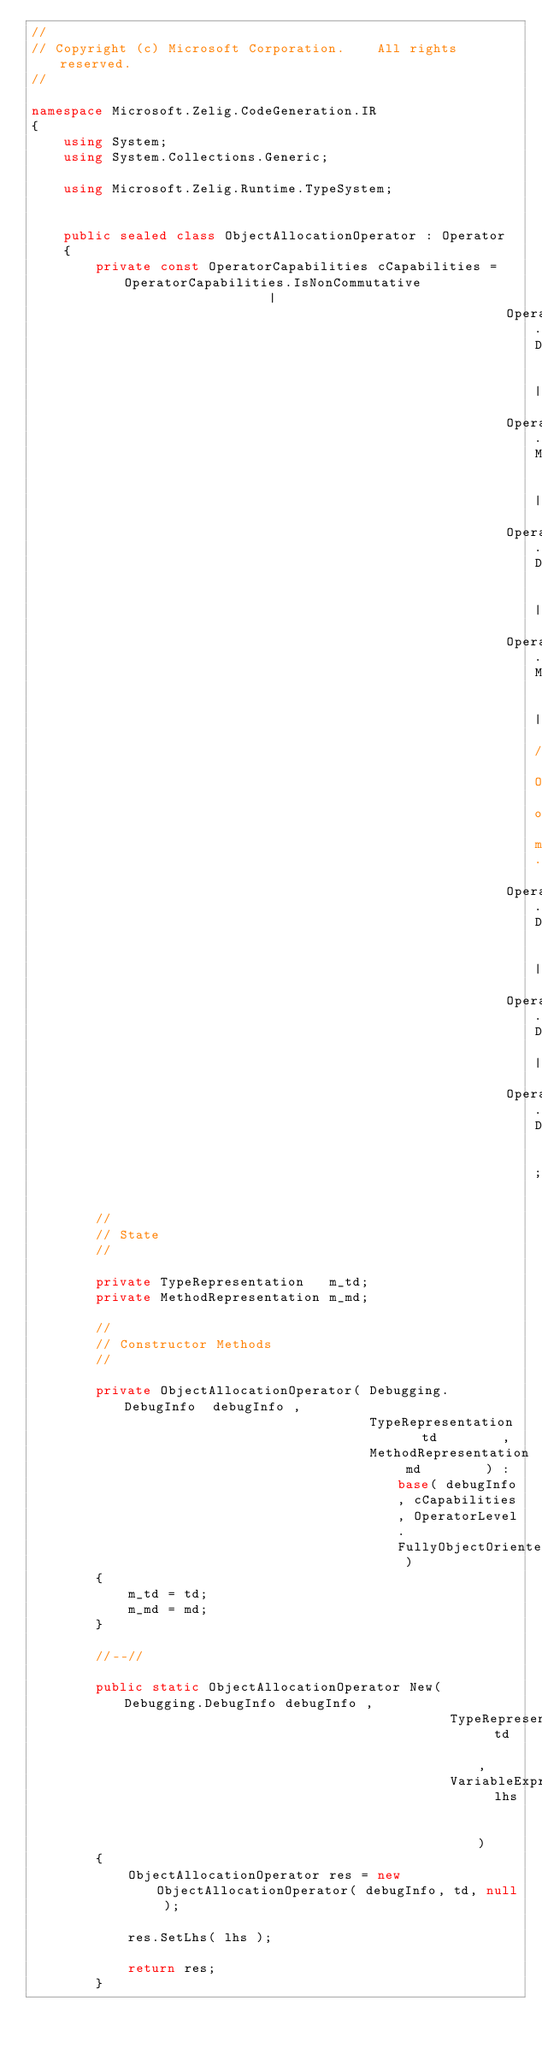Convert code to text. <code><loc_0><loc_0><loc_500><loc_500><_C#_>//
// Copyright (c) Microsoft Corporation.    All rights reserved.
//

namespace Microsoft.Zelig.CodeGeneration.IR
{
    using System;
    using System.Collections.Generic;

    using Microsoft.Zelig.Runtime.TypeSystem;


    public sealed class ObjectAllocationOperator : Operator
    {
        private const OperatorCapabilities cCapabilities = OperatorCapabilities.IsNonCommutative                   |
                                                           OperatorCapabilities.DoesNotMutateExistingStorage       |
                                                           OperatorCapabilities.MayAllocateStorage                 |
                                                           OperatorCapabilities.DoesNotReadExistingMutableStorage  |
                                                           OperatorCapabilities.MayThrow                           | // Out of memory.
                                                           OperatorCapabilities.DoesNotReadThroughPointerOperands  |
                                                           OperatorCapabilities.DoesNotWriteThroughPointerOperands |
                                                           OperatorCapabilities.DoesNotCapturePointerOperands      ;

        //
        // State
        //

        private TypeRepresentation   m_td;
        private MethodRepresentation m_md;

        //
        // Constructor Methods
        //

        private ObjectAllocationOperator( Debugging.DebugInfo  debugInfo ,
                                          TypeRepresentation   td        ,
                                          MethodRepresentation md        ) : base( debugInfo, cCapabilities, OperatorLevel.FullyObjectOriented )
        {
            m_td = td;
            m_md = md;
        }

        //--//

        public static ObjectAllocationOperator New( Debugging.DebugInfo debugInfo ,
                                                    TypeRepresentation  td        ,
                                                    VariableExpression  lhs       )
        {
            ObjectAllocationOperator res = new ObjectAllocationOperator( debugInfo, td, null );

            res.SetLhs( lhs );

            return res;
        }
</code> 